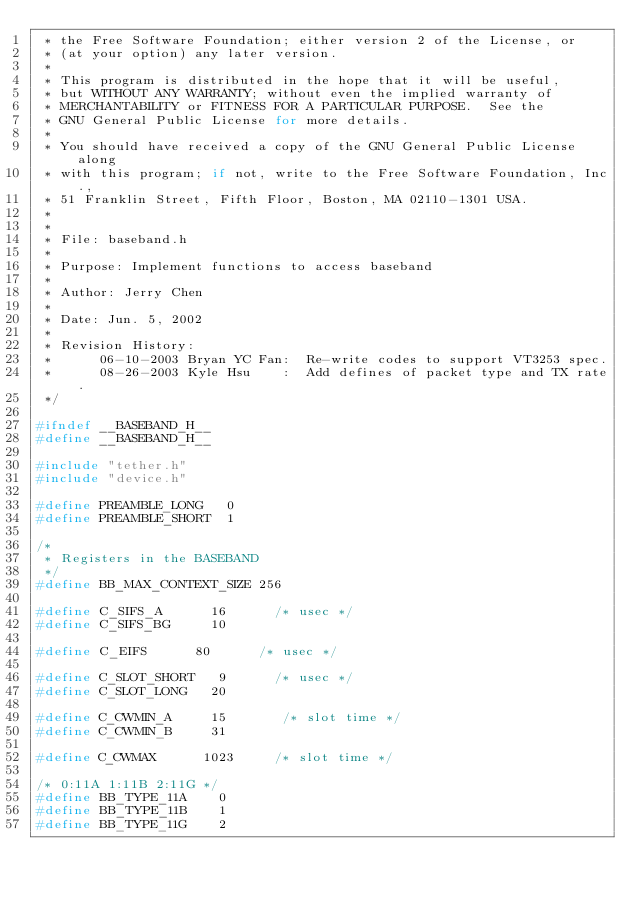<code> <loc_0><loc_0><loc_500><loc_500><_C_> * the Free Software Foundation; either version 2 of the License, or
 * (at your option) any later version.
 *
 * This program is distributed in the hope that it will be useful,
 * but WITHOUT ANY WARRANTY; without even the implied warranty of
 * MERCHANTABILITY or FITNESS FOR A PARTICULAR PURPOSE.  See the
 * GNU General Public License for more details.
 *
 * You should have received a copy of the GNU General Public License along
 * with this program; if not, write to the Free Software Foundation, Inc.,
 * 51 Franklin Street, Fifth Floor, Boston, MA 02110-1301 USA.
 *
 *
 * File: baseband.h
 *
 * Purpose: Implement functions to access baseband
 *
 * Author: Jerry Chen
 *
 * Date: Jun. 5, 2002
 *
 * Revision History:
 *      06-10-2003 Bryan YC Fan:  Re-write codes to support VT3253 spec.
 *      08-26-2003 Kyle Hsu    :  Add defines of packet type and TX rate.
 */

#ifndef __BASEBAND_H__
#define __BASEBAND_H__

#include "tether.h"
#include "device.h"

#define PREAMBLE_LONG   0
#define PREAMBLE_SHORT  1

/*
 * Registers in the BASEBAND
 */
#define BB_MAX_CONTEXT_SIZE 256

#define C_SIFS_A      16      /* usec */
#define C_SIFS_BG     10

#define C_EIFS      80      /* usec */

#define C_SLOT_SHORT   9      /* usec */
#define C_SLOT_LONG   20

#define C_CWMIN_A     15       /* slot time */
#define C_CWMIN_B     31

#define C_CWMAX      1023     /* slot time */

/* 0:11A 1:11B 2:11G */
#define BB_TYPE_11A    0
#define BB_TYPE_11B    1
#define BB_TYPE_11G    2
</code> 